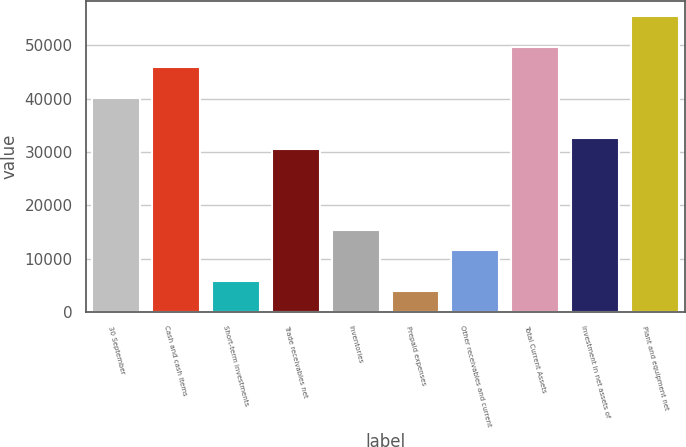Convert chart to OTSL. <chart><loc_0><loc_0><loc_500><loc_500><bar_chart><fcel>30 September<fcel>Cash and cash items<fcel>Short-term investments<fcel>Trade receivables net<fcel>Inventories<fcel>Prepaid expenses<fcel>Other receivables and current<fcel>Total Current Assets<fcel>Investment in net assets of<fcel>Plant and equipment net<nl><fcel>40214.7<fcel>45951.9<fcel>5791.5<fcel>30652.7<fcel>15353.5<fcel>3879.1<fcel>11528.7<fcel>49776.7<fcel>32565.1<fcel>55513.9<nl></chart> 